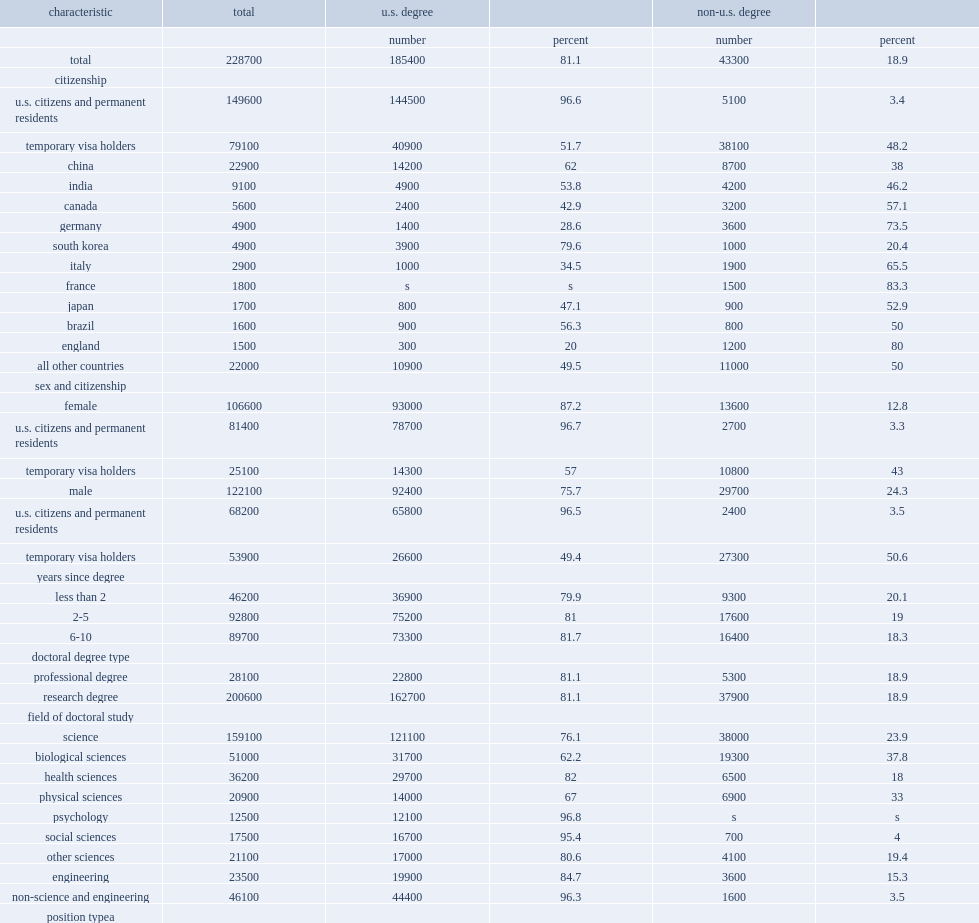How many percent did u.s. citizens and permanent residents account of the early career doctorates population in 2015? 0.654132. How many percent of earning their first doctorate from a u.s. academic institution? 96.6. Among the early career doctorates on a temporary visa, how many percent were foreign trained? 48.2. 